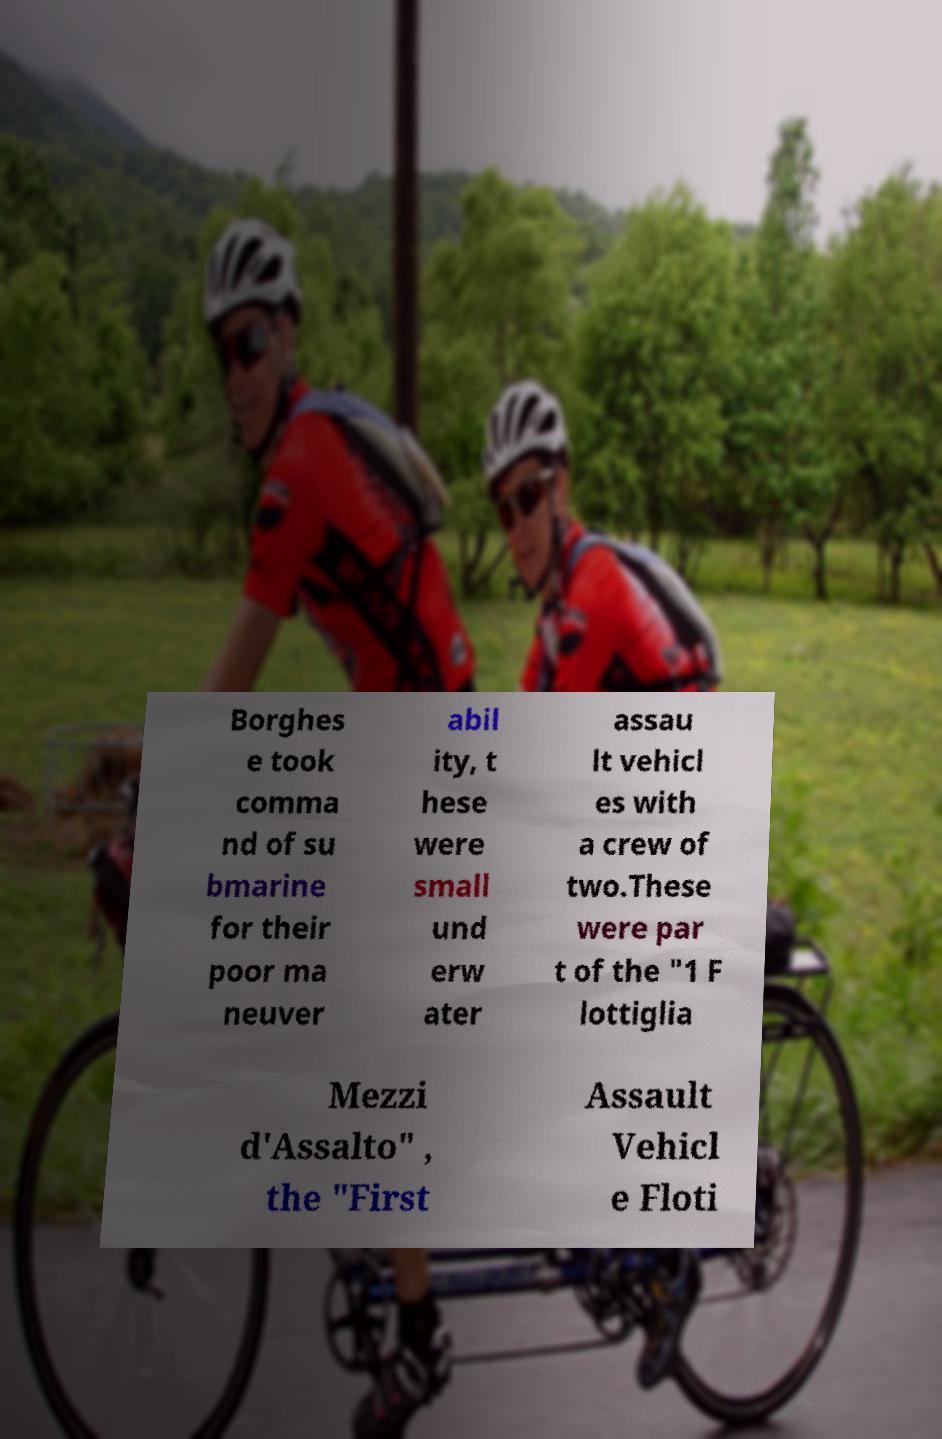Can you accurately transcribe the text from the provided image for me? Borghes e took comma nd of su bmarine for their poor ma neuver abil ity, t hese were small und erw ater assau lt vehicl es with a crew of two.These were par t of the "1 F lottiglia Mezzi d'Assalto" , the "First Assault Vehicl e Floti 